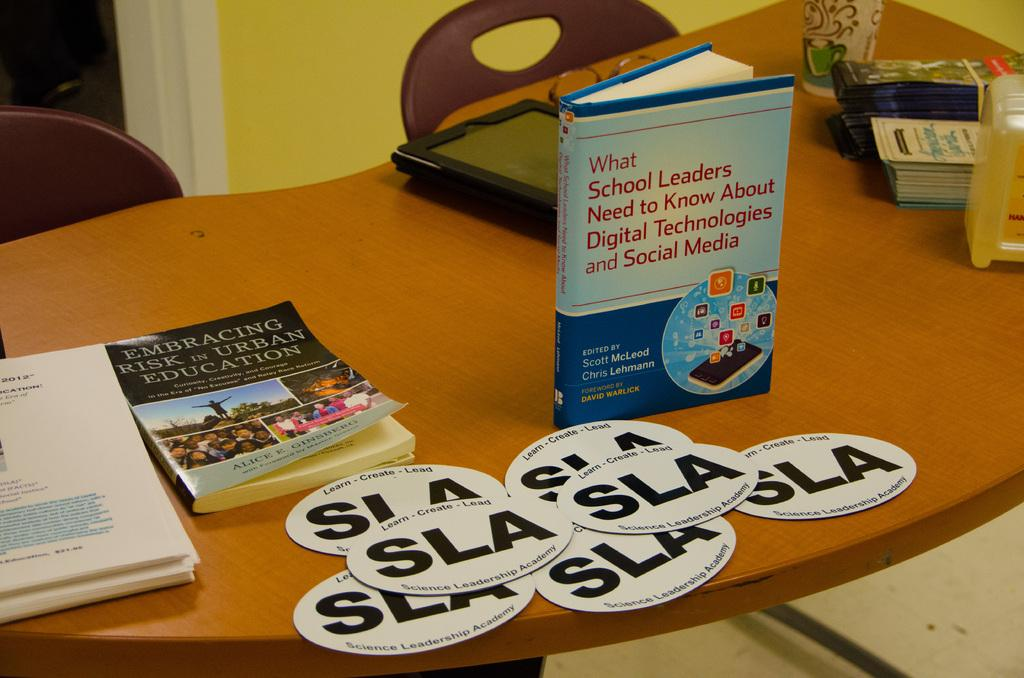Provide a one-sentence caption for the provided image. Several books are on a table including Embracing Risk in Urban Education. 